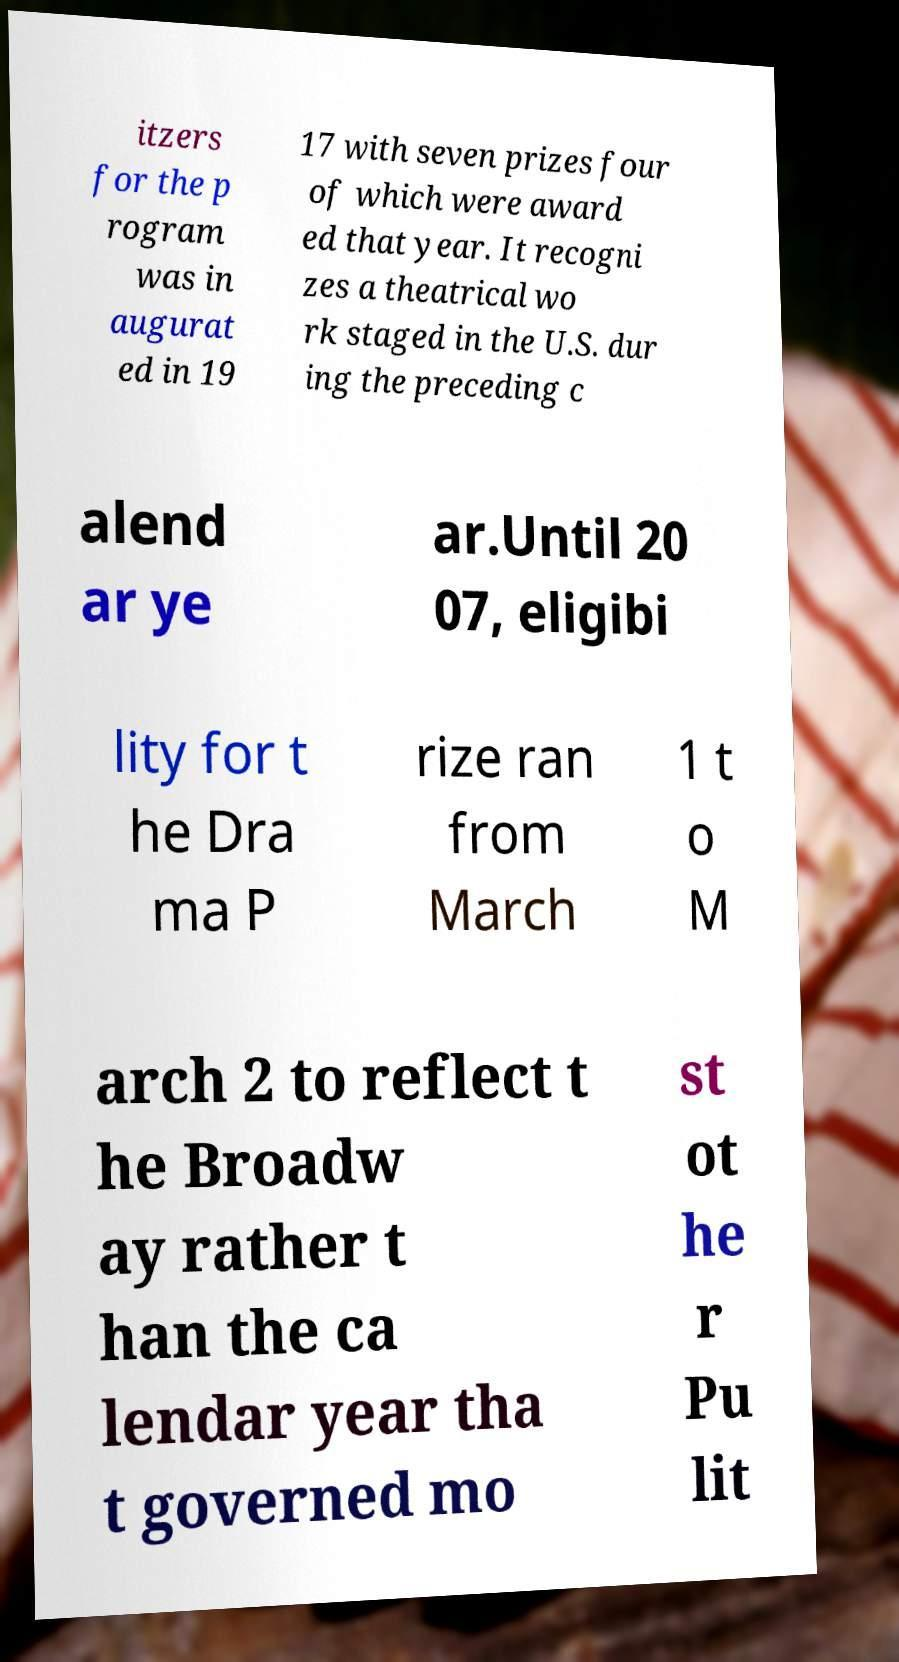What messages or text are displayed in this image? I need them in a readable, typed format. itzers for the p rogram was in augurat ed in 19 17 with seven prizes four of which were award ed that year. It recogni zes a theatrical wo rk staged in the U.S. dur ing the preceding c alend ar ye ar.Until 20 07, eligibi lity for t he Dra ma P rize ran from March 1 t o M arch 2 to reflect t he Broadw ay rather t han the ca lendar year tha t governed mo st ot he r Pu lit 